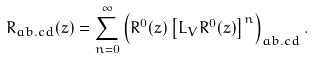Convert formula to latex. <formula><loc_0><loc_0><loc_500><loc_500>R _ { a b . c d } ( z ) = \sum _ { n = 0 } ^ { \infty } \left ( R ^ { 0 } ( z ) \left [ L _ { V } R ^ { 0 } ( z ) \right ] ^ { n } \right ) _ { a b . c d } .</formula> 